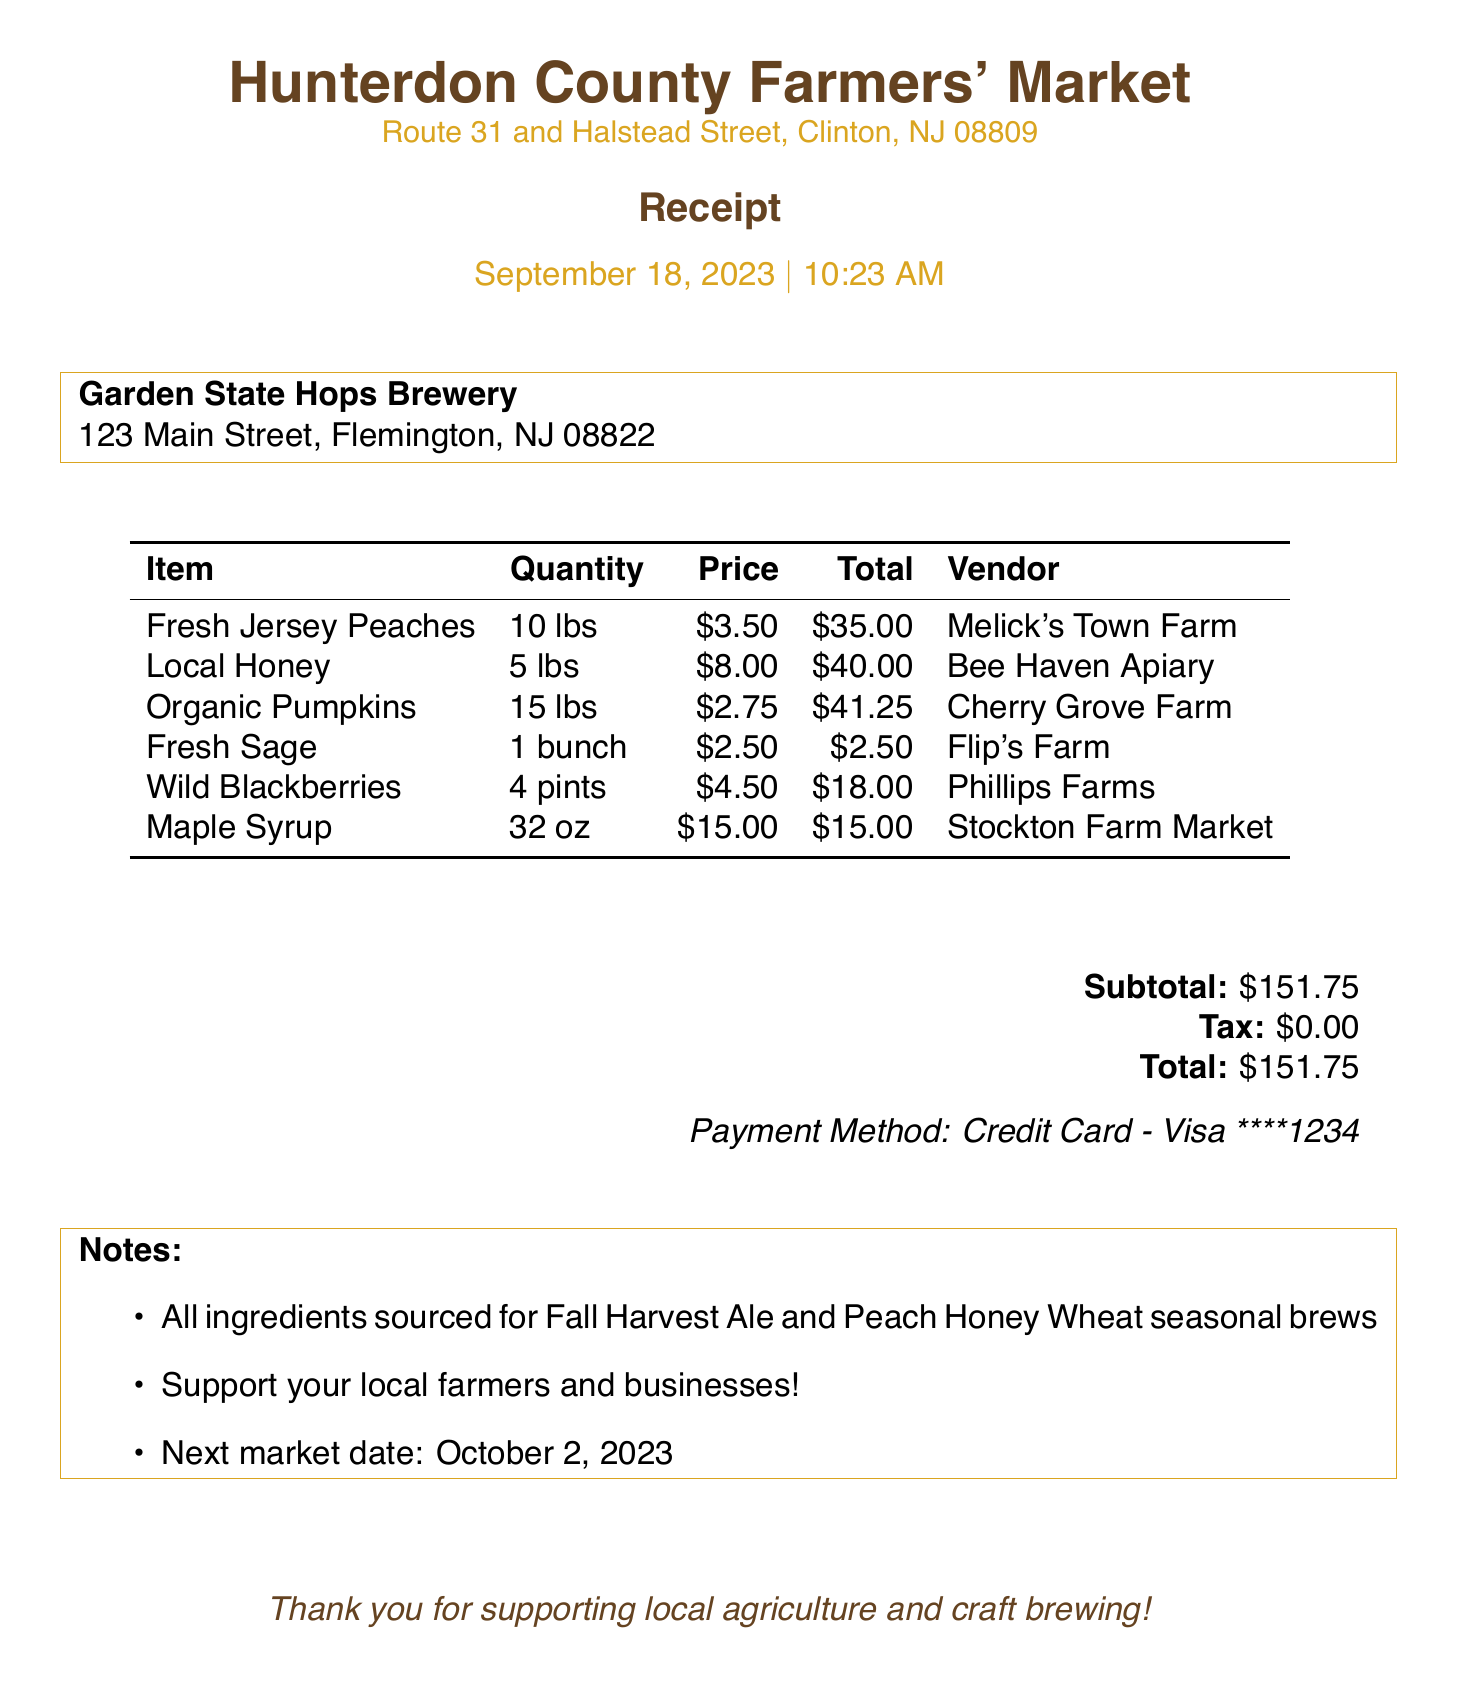what is the name of the market? The receipt states the market name as Hunterdon County Farmers' Market.
Answer: Hunterdon County Farmers' Market what is the total amount paid? The total amount paid is indicated in the payment information section, which is $151.75.
Answer: $151.75 who provided the Fresh Jersey Peaches? The vendor for Fresh Jersey Peaches can be found in the itemized list, which states Melick's Town Farm.
Answer: Melick's Town Farm how many pounds of Organic Pumpkins were purchased? The quantity for Organic Pumpkins is shown in the itemized list as 15 lbs.
Answer: 15 lbs when is the next market date? The notes section includes the next market date as October 2, 2023.
Answer: October 2, 2023 what type of payment was used? The payment method is specified in the payment information, which is a Credit Card - Visa.
Answer: Credit Card - Visa what is the subtotal before tax? The subtotal amount is mentioned in the payment information section and is $151.75.
Answer: $151.75 how many pints of Wild Blackberries were bought? The item list indicates that 4 pints of Wild Blackberries were purchased.
Answer: 4 pints which brews are the ingredients sourced for? The notes mention that the ingredients are sourced for Fall Harvest Ale and Peach Honey Wheat seasonal brews.
Answer: Fall Harvest Ale and Peach Honey Wheat 